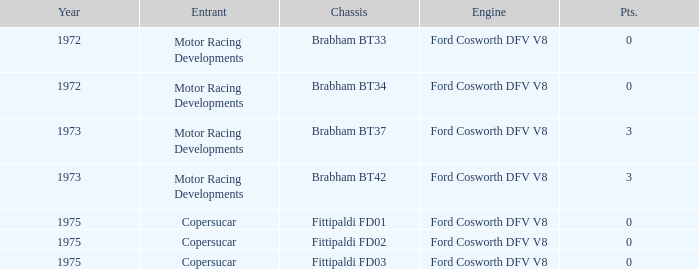Which engine from 1973 has a Brabham bt37 chassis? Ford Cosworth DFV V8. 